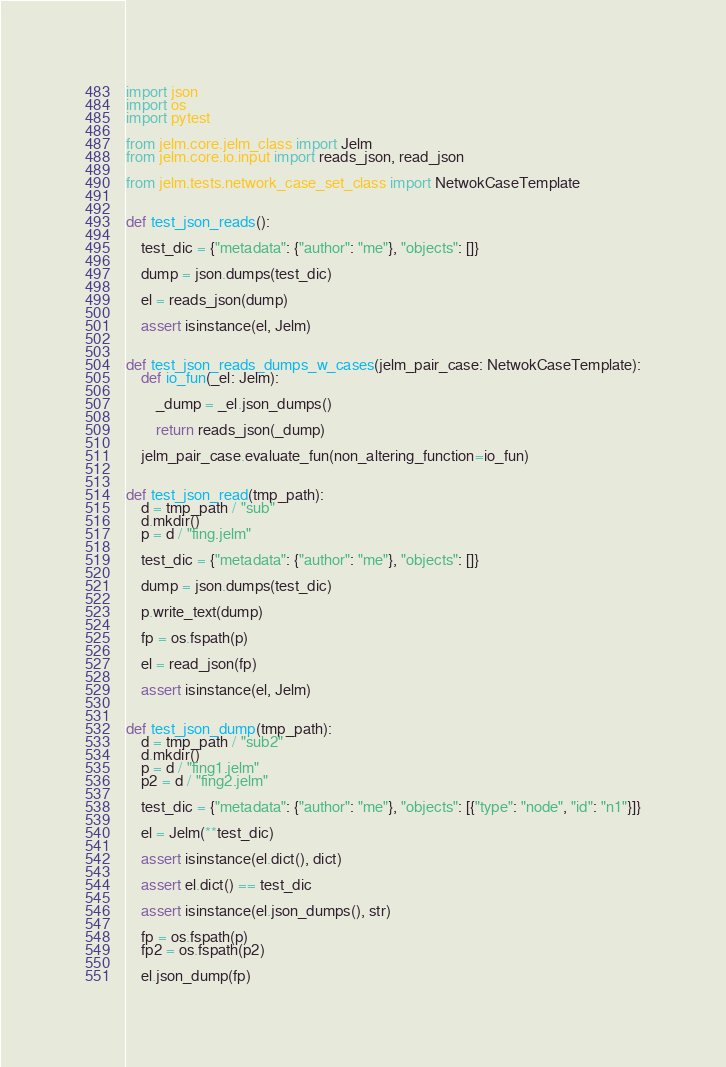<code> <loc_0><loc_0><loc_500><loc_500><_Python_>import json
import os
import pytest

from jelm.core.jelm_class import Jelm
from jelm.core.io.input import reads_json, read_json

from jelm.tests.network_case_set_class import NetwokCaseTemplate


def test_json_reads():

    test_dic = {"metadata": {"author": "me"}, "objects": []}

    dump = json.dumps(test_dic)

    el = reads_json(dump)

    assert isinstance(el, Jelm)


def test_json_reads_dumps_w_cases(jelm_pair_case: NetwokCaseTemplate):
    def io_fun(_el: Jelm):

        _dump = _el.json_dumps()

        return reads_json(_dump)

    jelm_pair_case.evaluate_fun(non_altering_function=io_fun)


def test_json_read(tmp_path):
    d = tmp_path / "sub"
    d.mkdir()
    p = d / "fing.jelm"

    test_dic = {"metadata": {"author": "me"}, "objects": []}

    dump = json.dumps(test_dic)

    p.write_text(dump)

    fp = os.fspath(p)

    el = read_json(fp)

    assert isinstance(el, Jelm)


def test_json_dump(tmp_path):
    d = tmp_path / "sub2"
    d.mkdir()
    p = d / "fing1.jelm"
    p2 = d / "fing2.jelm"

    test_dic = {"metadata": {"author": "me"}, "objects": [{"type": "node", "id": "n1"}]}

    el = Jelm(**test_dic)

    assert isinstance(el.dict(), dict)

    assert el.dict() == test_dic

    assert isinstance(el.json_dumps(), str)

    fp = os.fspath(p)
    fp2 = os.fspath(p2)

    el.json_dump(fp)</code> 